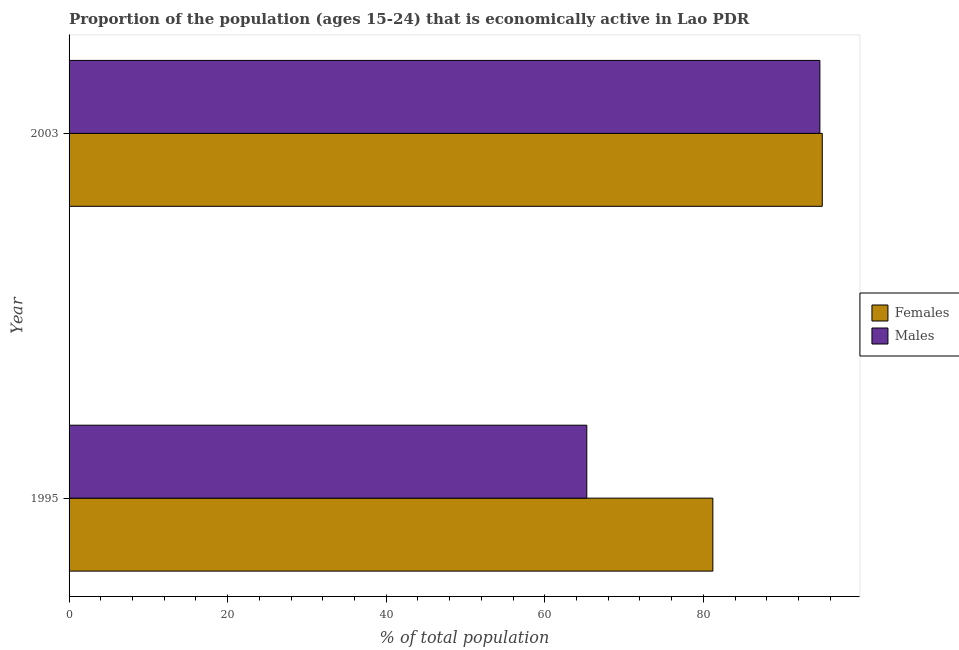How many different coloured bars are there?
Give a very brief answer. 2. Across all years, what is the maximum percentage of economically active female population?
Provide a succinct answer. 95. Across all years, what is the minimum percentage of economically active male population?
Ensure brevity in your answer.  65.3. In which year was the percentage of economically active male population maximum?
Offer a terse response. 2003. What is the total percentage of economically active male population in the graph?
Offer a terse response. 160. What is the difference between the percentage of economically active female population in 1995 and that in 2003?
Make the answer very short. -13.8. What is the difference between the percentage of economically active male population in 1995 and the percentage of economically active female population in 2003?
Provide a short and direct response. -29.7. In the year 2003, what is the difference between the percentage of economically active female population and percentage of economically active male population?
Provide a short and direct response. 0.3. In how many years, is the percentage of economically active female population greater than 68 %?
Your answer should be compact. 2. What is the ratio of the percentage of economically active female population in 1995 to that in 2003?
Your response must be concise. 0.85. Is the percentage of economically active male population in 1995 less than that in 2003?
Your response must be concise. Yes. What does the 1st bar from the top in 2003 represents?
Your answer should be compact. Males. What does the 2nd bar from the bottom in 2003 represents?
Provide a succinct answer. Males. Are all the bars in the graph horizontal?
Make the answer very short. Yes. Are the values on the major ticks of X-axis written in scientific E-notation?
Provide a succinct answer. No. Does the graph contain any zero values?
Offer a very short reply. No. Does the graph contain grids?
Ensure brevity in your answer.  No. How many legend labels are there?
Offer a terse response. 2. What is the title of the graph?
Make the answer very short. Proportion of the population (ages 15-24) that is economically active in Lao PDR. Does "Formally registered" appear as one of the legend labels in the graph?
Keep it short and to the point. No. What is the label or title of the X-axis?
Provide a short and direct response. % of total population. What is the label or title of the Y-axis?
Offer a terse response. Year. What is the % of total population in Females in 1995?
Your answer should be compact. 81.2. What is the % of total population of Males in 1995?
Provide a succinct answer. 65.3. What is the % of total population in Females in 2003?
Your answer should be very brief. 95. What is the % of total population in Males in 2003?
Make the answer very short. 94.7. Across all years, what is the maximum % of total population of Males?
Give a very brief answer. 94.7. Across all years, what is the minimum % of total population of Females?
Keep it short and to the point. 81.2. Across all years, what is the minimum % of total population of Males?
Provide a succinct answer. 65.3. What is the total % of total population of Females in the graph?
Make the answer very short. 176.2. What is the total % of total population of Males in the graph?
Offer a very short reply. 160. What is the difference between the % of total population of Females in 1995 and that in 2003?
Keep it short and to the point. -13.8. What is the difference between the % of total population in Males in 1995 and that in 2003?
Provide a succinct answer. -29.4. What is the average % of total population of Females per year?
Ensure brevity in your answer.  88.1. What is the average % of total population of Males per year?
Offer a very short reply. 80. In the year 1995, what is the difference between the % of total population in Females and % of total population in Males?
Keep it short and to the point. 15.9. What is the ratio of the % of total population in Females in 1995 to that in 2003?
Ensure brevity in your answer.  0.85. What is the ratio of the % of total population in Males in 1995 to that in 2003?
Ensure brevity in your answer.  0.69. What is the difference between the highest and the second highest % of total population of Females?
Provide a short and direct response. 13.8. What is the difference between the highest and the second highest % of total population in Males?
Ensure brevity in your answer.  29.4. What is the difference between the highest and the lowest % of total population in Males?
Your answer should be very brief. 29.4. 